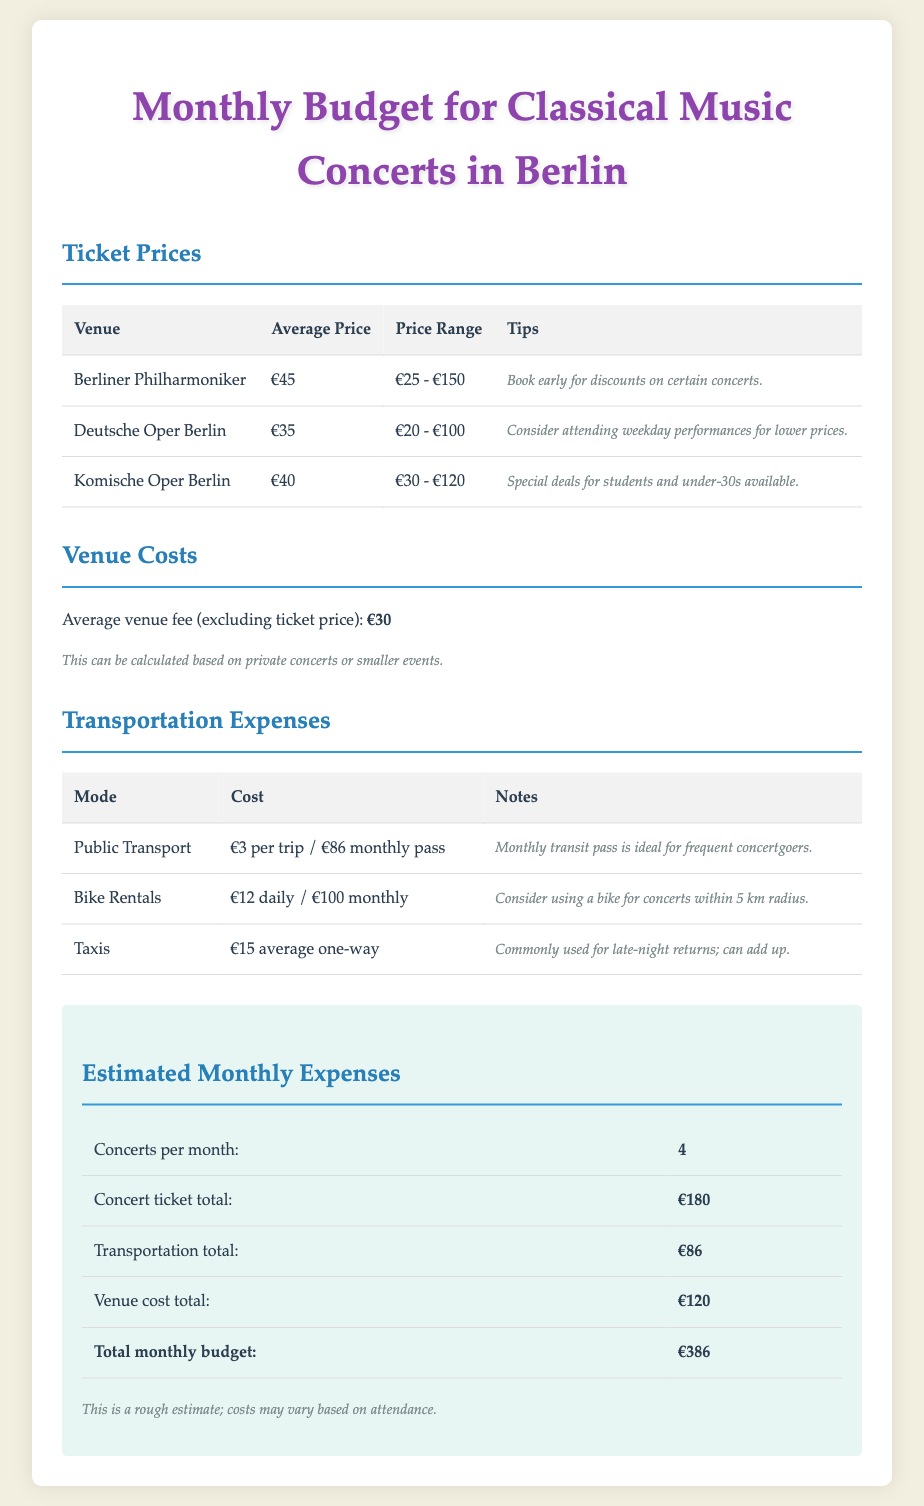What is the average ticket price at the Berliner Philharmoniker? The average ticket price at the Berliner Philharmoniker is listed in the document, specifically stated as €45.
Answer: €45 What is the price range for tickets at the Deutsche Oper Berlin? The price range for tickets at the Deutsche Oper Berlin is found in the document under the ticket prices section, which is €20 - €100.
Answer: €20 - €100 What is the average venue fee mentioned in the document? The document specifies the average venue fee (excluding ticket price) as €30.
Answer: €30 How many concerts per month is the estimated budget based on? The estimated budget is based on attending 4 concerts per month, as mentioned in the summary section.
Answer: 4 What is the total monthly budget for attending concerts in Berlin? The total monthly budget is clearly outlined in the summary, calculated as €386.
Answer: €386 What is the cost of a monthly public transport pass? The cost of a monthly public transport pass is indicated in the transportation expenses table as €86.
Answer: €86 Which venue has an average ticket price of €40? The document lists the Komische Oper Berlin having an average ticket price of €40.
Answer: Komische Oper Berlin What is the average cost of a taxi one-way? The average cost of a taxi for a one-way trip is mentioned as €15 in the transport expenses section.
Answer: €15 What special deals are available at the Komische Oper Berlin? The document notes that special deals for students and under-30s are available at the Komische Oper Berlin.
Answer: Special deals for students and under-30s 